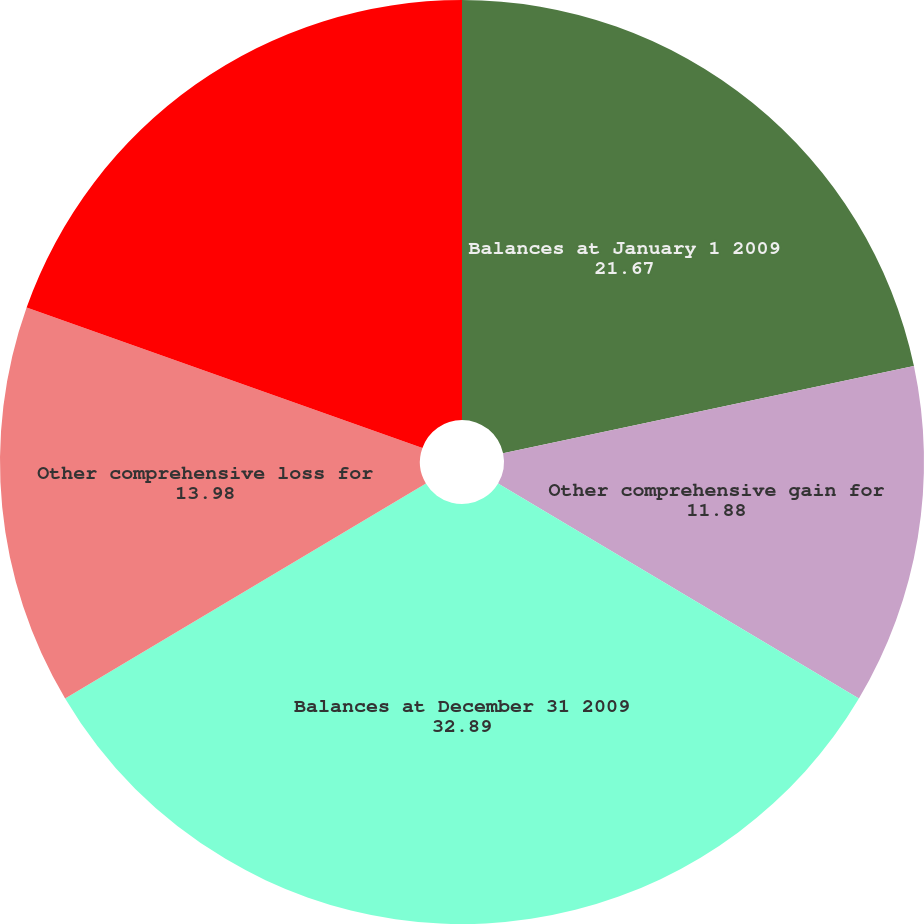<chart> <loc_0><loc_0><loc_500><loc_500><pie_chart><fcel>Balances at January 1 2009<fcel>Other comprehensive gain for<fcel>Balances at December 31 2009<fcel>Other comprehensive loss for<fcel>Balances at December 31 2010<nl><fcel>21.67%<fcel>11.88%<fcel>32.89%<fcel>13.98%<fcel>19.57%<nl></chart> 